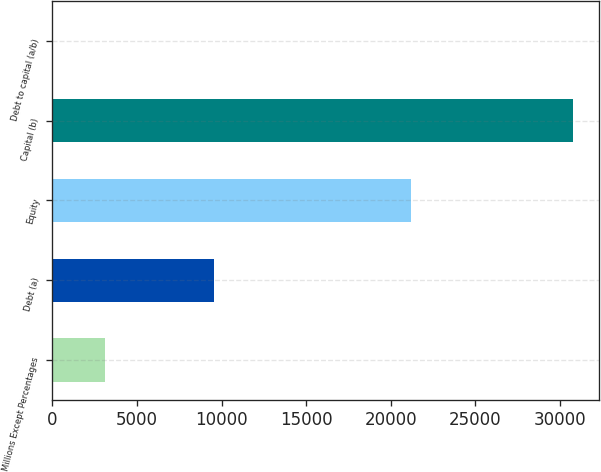<chart> <loc_0><loc_0><loc_500><loc_500><bar_chart><fcel>Millions Except Percentages<fcel>Debt (a)<fcel>Equity<fcel>Capital (b)<fcel>Debt to capital (a/b)<nl><fcel>3108.19<fcel>9577<fcel>21225<fcel>30802<fcel>31.1<nl></chart> 